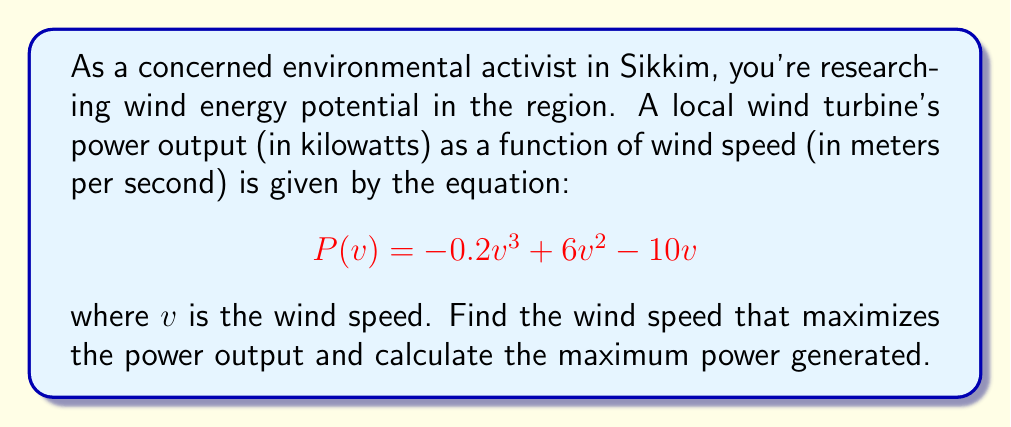Provide a solution to this math problem. To find the maximum efficiency point, we need to find the maximum of the function $P(v)$. This occurs where the derivative $P'(v)$ is zero.

Step 1: Find the derivative of $P(v)$
$$P'(v) = -0.6v^2 + 12v - 10$$

Step 2: Set $P'(v) = 0$ and solve for $v$
$$-0.6v^2 + 12v - 10 = 0$$

This is a quadratic equation. We can solve it using the quadratic formula:
$$v = \frac{-b \pm \sqrt{b^2 - 4ac}}{2a}$$

where $a = -0.6$, $b = 12$, and $c = -10$

$$v = \frac{-12 \pm \sqrt{12^2 - 4(-0.6)(-10)}}{2(-0.6)}$$
$$v = \frac{-12 \pm \sqrt{144 - 24}}{-1.2}$$
$$v = \frac{-12 \pm \sqrt{120}}{-1.2}$$
$$v = \frac{-12 \pm 10.95}{-1.2}$$

This gives us two solutions:
$$v_1 = \frac{-12 + 10.95}{-1.2} \approx 0.875$$
$$v_2 = \frac{-12 - 10.95}{-1.2} \approx 19.125$$

Step 3: Determine which solution gives the maximum
We can check the second derivative $P''(v) = -1.2v + 12$ at these points:

At $v_1 = 0.875$: $P''(0.875) = 10.95 > 0$, so this is a local minimum.
At $v_2 = 19.125$: $P''(19.125) = -10.95 < 0$, so this is a local maximum.

Therefore, the maximum occurs at $v = 19.125$ m/s.

Step 4: Calculate the maximum power output
$$P(19.125) = -0.2(19.125)^3 + 6(19.125)^2 - 10(19.125) \approx 728.8 \text{ kW}$$
Answer: Maximum power output of 728.8 kW at wind speed 19.125 m/s 